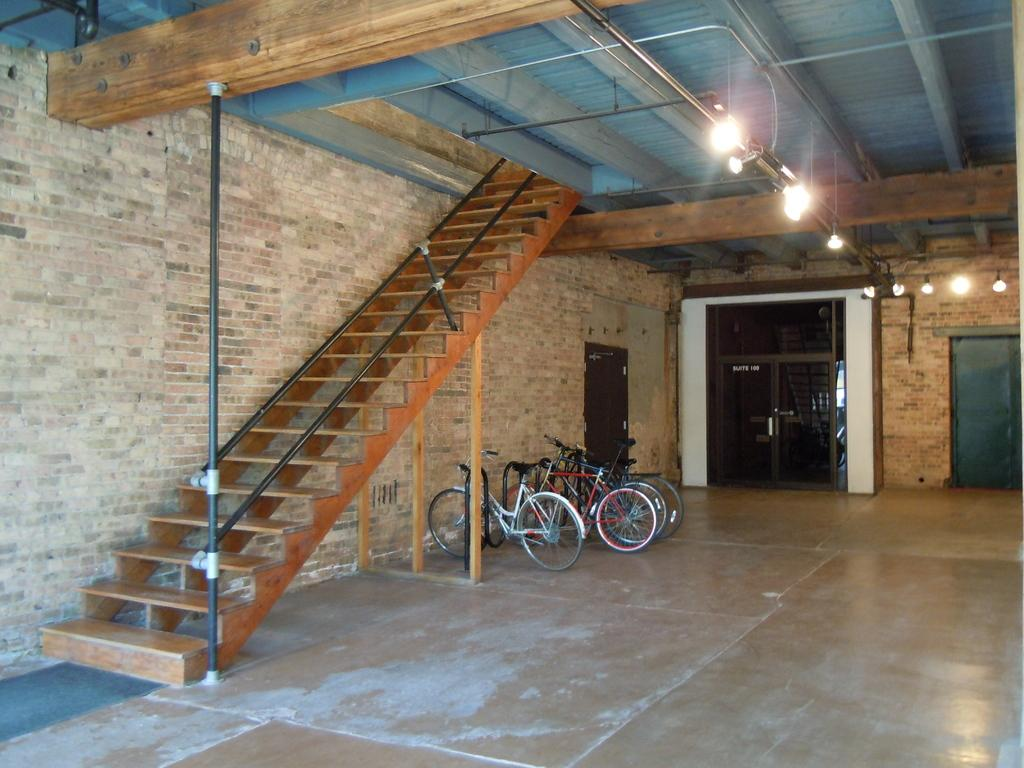What type of structure can be seen in the image? There is a wall in the image. What architectural feature is present in the image? There are stairs in the image. What mode of transportation is visible in the image? There are bicycles in the image. What can be used for illumination in the image? There are lights in the image. What type of entrance or exit is present in the image? There are doors in the image. What thought or memory is depicted in the image? There is no thought or memory depicted in the image; it features a wall, stairs, bicycles, lights, and doors. Can you tell me how many toads are present in the image? There are no toads present in the image. 